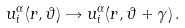<formula> <loc_0><loc_0><loc_500><loc_500>u _ { i } ^ { \alpha } ( r , \vartheta ) \rightarrow u _ { i } ^ { \alpha } ( r , \vartheta + \gamma ) \, .</formula> 